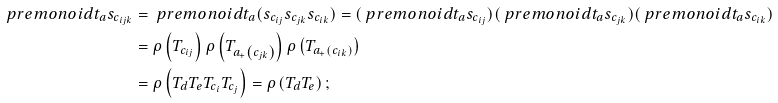<formula> <loc_0><loc_0><loc_500><loc_500>\ p r e m o n o i d { t _ { a } } { s _ { c _ { i j k } } } & = \ p r e m o n o i d { t _ { a } } { ( s _ { c _ { i j } } s _ { c _ { j k } } s _ { c _ { i k } } ) } = ( \ p r e m o n o i d { t _ { a } } { s _ { c _ { i j } } } ) ( \ p r e m o n o i d { t _ { a } } { s _ { c _ { j k } } } ) ( \ p r e m o n o i d { t _ { a } } { s _ { c _ { i k } } } ) \\ & = \rho \left ( T _ { c _ { i j } } \right ) \rho \left ( T _ { a _ { + } \left ( c _ { j k } \right ) } \right ) \rho \left ( T _ { a _ { + } \left ( c _ { i k } \right ) } \right ) \\ & = \rho \left ( T _ { d } T _ { e } T _ { c _ { i } } T _ { c _ { j } } \right ) = \rho \left ( T _ { d } T _ { e } \right ) ;</formula> 